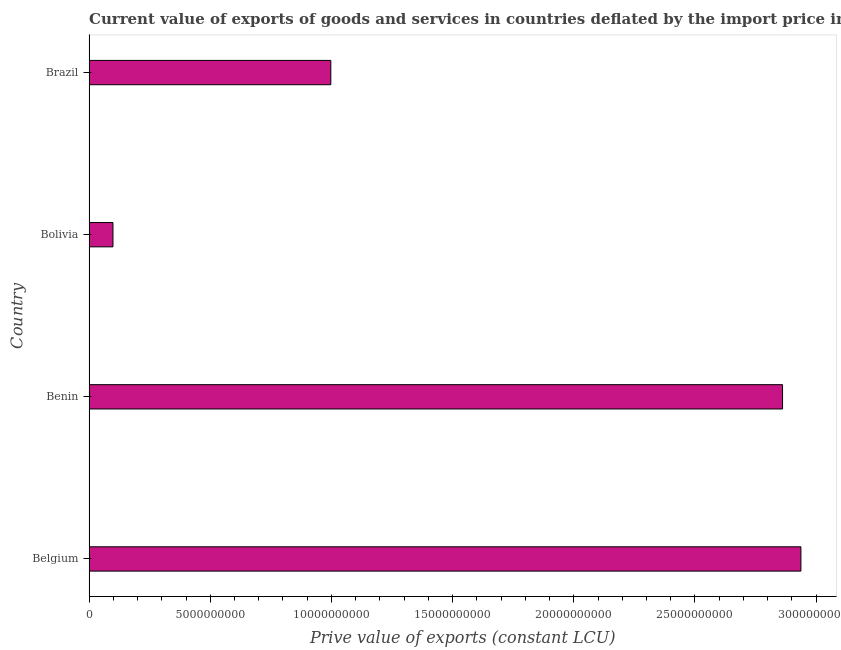Does the graph contain any zero values?
Keep it short and to the point. No. What is the title of the graph?
Your answer should be compact. Current value of exports of goods and services in countries deflated by the import price index. What is the label or title of the X-axis?
Make the answer very short. Prive value of exports (constant LCU). What is the label or title of the Y-axis?
Make the answer very short. Country. What is the price value of exports in Benin?
Provide a succinct answer. 2.86e+1. Across all countries, what is the maximum price value of exports?
Offer a very short reply. 2.94e+1. Across all countries, what is the minimum price value of exports?
Offer a terse response. 9.85e+08. In which country was the price value of exports maximum?
Your answer should be very brief. Belgium. In which country was the price value of exports minimum?
Your answer should be compact. Bolivia. What is the sum of the price value of exports?
Ensure brevity in your answer.  6.89e+1. What is the difference between the price value of exports in Belgium and Brazil?
Provide a succinct answer. 1.94e+1. What is the average price value of exports per country?
Provide a short and direct response. 1.72e+1. What is the median price value of exports?
Your answer should be very brief. 1.93e+1. In how many countries, is the price value of exports greater than 17000000000 LCU?
Ensure brevity in your answer.  2. What is the ratio of the price value of exports in Bolivia to that in Brazil?
Keep it short and to the point. 0.1. Is the price value of exports in Benin less than that in Bolivia?
Keep it short and to the point. No. Is the difference between the price value of exports in Belgium and Benin greater than the difference between any two countries?
Offer a very short reply. No. What is the difference between the highest and the second highest price value of exports?
Ensure brevity in your answer.  7.58e+08. What is the difference between the highest and the lowest price value of exports?
Your response must be concise. 2.84e+1. How many bars are there?
Give a very brief answer. 4. Are all the bars in the graph horizontal?
Offer a terse response. Yes. How many countries are there in the graph?
Provide a short and direct response. 4. What is the difference between two consecutive major ticks on the X-axis?
Provide a short and direct response. 5.00e+09. What is the Prive value of exports (constant LCU) of Belgium?
Offer a very short reply. 2.94e+1. What is the Prive value of exports (constant LCU) in Benin?
Your response must be concise. 2.86e+1. What is the Prive value of exports (constant LCU) in Bolivia?
Offer a very short reply. 9.85e+08. What is the Prive value of exports (constant LCU) of Brazil?
Your response must be concise. 9.97e+09. What is the difference between the Prive value of exports (constant LCU) in Belgium and Benin?
Make the answer very short. 7.58e+08. What is the difference between the Prive value of exports (constant LCU) in Belgium and Bolivia?
Offer a terse response. 2.84e+1. What is the difference between the Prive value of exports (constant LCU) in Belgium and Brazil?
Offer a terse response. 1.94e+1. What is the difference between the Prive value of exports (constant LCU) in Benin and Bolivia?
Keep it short and to the point. 2.76e+1. What is the difference between the Prive value of exports (constant LCU) in Benin and Brazil?
Give a very brief answer. 1.86e+1. What is the difference between the Prive value of exports (constant LCU) in Bolivia and Brazil?
Offer a very short reply. -8.99e+09. What is the ratio of the Prive value of exports (constant LCU) in Belgium to that in Bolivia?
Give a very brief answer. 29.82. What is the ratio of the Prive value of exports (constant LCU) in Belgium to that in Brazil?
Keep it short and to the point. 2.94. What is the ratio of the Prive value of exports (constant LCU) in Benin to that in Bolivia?
Make the answer very short. 29.05. What is the ratio of the Prive value of exports (constant LCU) in Benin to that in Brazil?
Make the answer very short. 2.87. What is the ratio of the Prive value of exports (constant LCU) in Bolivia to that in Brazil?
Give a very brief answer. 0.1. 